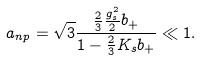Convert formula to latex. <formula><loc_0><loc_0><loc_500><loc_500>a _ { n p } = \sqrt { 3 } \frac { \frac { 2 } { 3 } \frac { g _ { s } ^ { 2 } } { 2 } b _ { + } } { 1 - \frac { 2 } { 3 } K _ { s } b _ { + } } \ll 1 .</formula> 